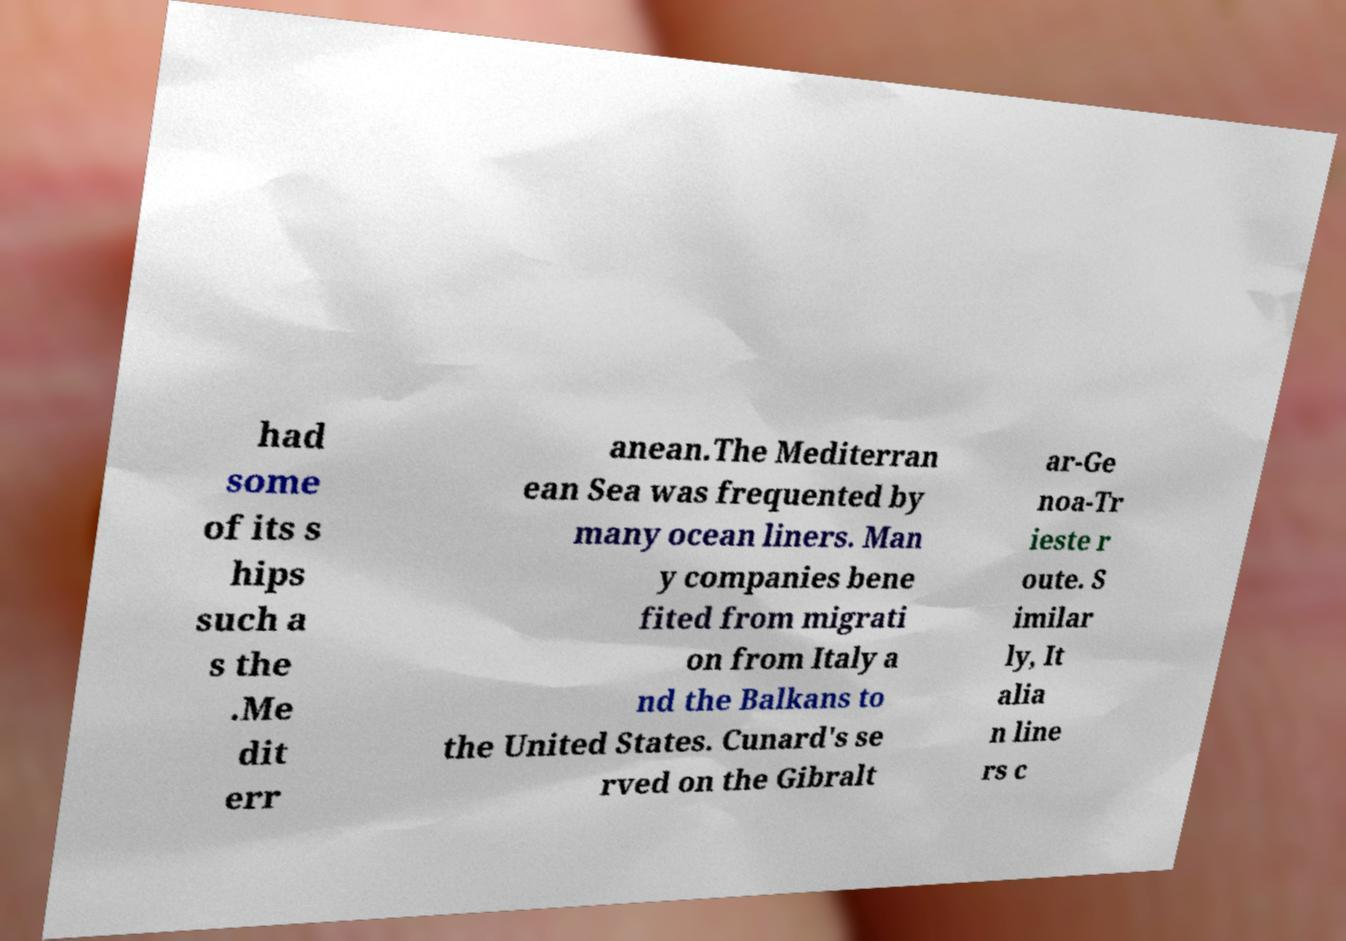Please identify and transcribe the text found in this image. had some of its s hips such a s the .Me dit err anean.The Mediterran ean Sea was frequented by many ocean liners. Man y companies bene fited from migrati on from Italy a nd the Balkans to the United States. Cunard's se rved on the Gibralt ar-Ge noa-Tr ieste r oute. S imilar ly, It alia n line rs c 